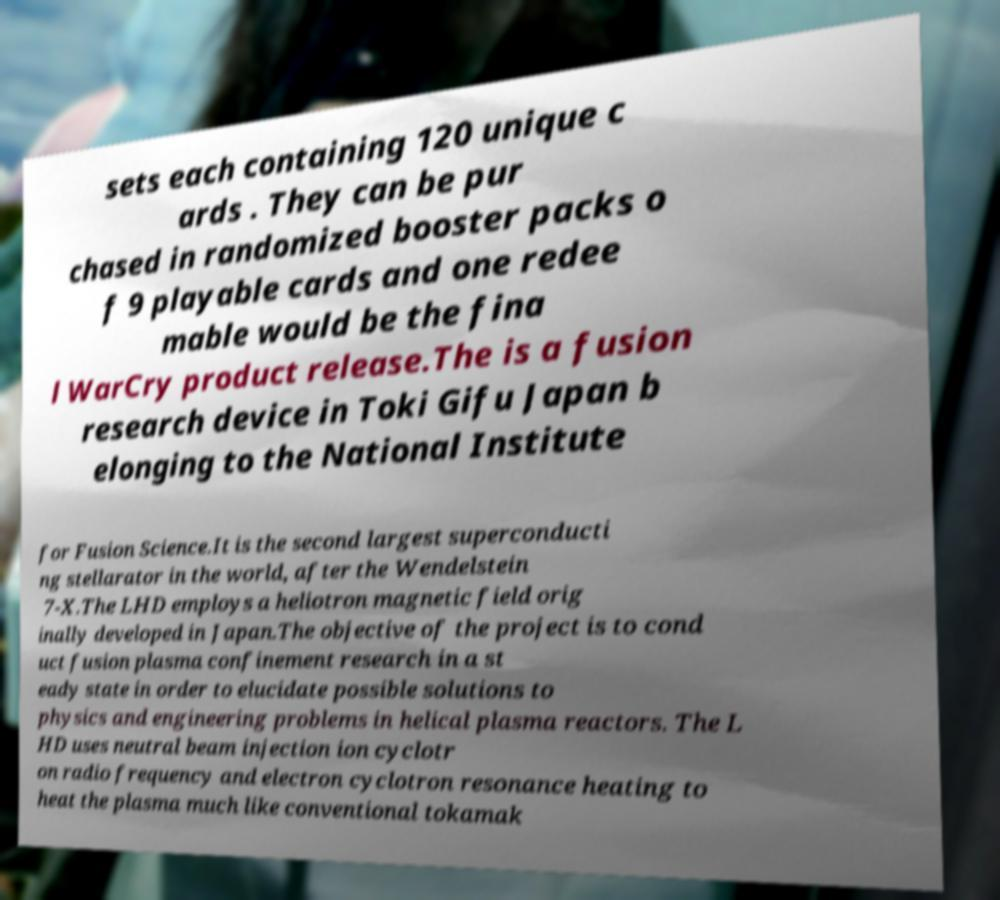For documentation purposes, I need the text within this image transcribed. Could you provide that? sets each containing 120 unique c ards . They can be pur chased in randomized booster packs o f 9 playable cards and one redee mable would be the fina l WarCry product release.The is a fusion research device in Toki Gifu Japan b elonging to the National Institute for Fusion Science.It is the second largest superconducti ng stellarator in the world, after the Wendelstein 7-X.The LHD employs a heliotron magnetic field orig inally developed in Japan.The objective of the project is to cond uct fusion plasma confinement research in a st eady state in order to elucidate possible solutions to physics and engineering problems in helical plasma reactors. The L HD uses neutral beam injection ion cyclotr on radio frequency and electron cyclotron resonance heating to heat the plasma much like conventional tokamak 